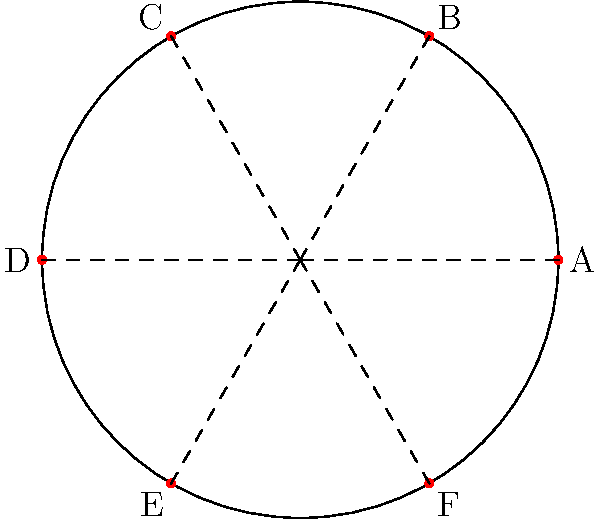Consider the circular layout of an ancient African village represented in the diagram. The village has 6 equally spaced dwellings around its perimeter. What is the order of the rotational symmetry group for this layout, and how does it relate to the cyclic group $C_6$? To determine the order of the rotational symmetry group and its relation to $C_6$, let's follow these steps:

1. Identify the symmetries:
   The village layout has 6 equally spaced dwellings, labeled A to F.

2. Determine possible rotations:
   - 0° (identity): No rotation
   - 60°: Rotation by 1/6 of a full turn
   - 120°: Rotation by 1/3 of a full turn
   - 180°: Rotation by 1/2 of a full turn
   - 240°: Rotation by 2/3 of a full turn
   - 300°: Rotation by 5/6 of a full turn

3. Count the number of distinct rotations:
   There are 6 distinct rotations, including the identity rotation.

4. Define the group:
   The rotational symmetry group of this layout is isomorphic to the cyclic group $C_6$.

5. Group properties:
   - The group has order 6.
   - It is generated by a single 60° rotation.
   - The group operation is composition of rotations.

6. Relation to $C_6$:
   - $C_6$ is the cyclic group of order 6.
   - It can be represented as $\{0, 1, 2, 3, 4, 5\}$ under addition modulo 6.
   - Each element in $C_6$ corresponds to a rotation in our village layout:
     0 → 0°, 1 → 60°, 2 → 120°, 3 → 180°, 4 → 240°, 5 → 300°

Therefore, the rotational symmetry group of the village layout is isomorphic to $C_6$, with an order of 6.
Answer: Order 6, isomorphic to $C_6$ 